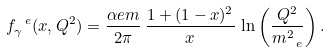Convert formula to latex. <formula><loc_0><loc_0><loc_500><loc_500>f _ { \gamma } ^ { \ e } ( x , Q ^ { 2 } ) = \frac { \alpha e m } { 2 \pi } \, \frac { 1 + ( 1 - x ) ^ { 2 } } { x } \, \ln \left ( \frac { Q ^ { 2 } } { m _ { \ e } ^ { 2 } } \right ) .</formula> 